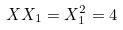Convert formula to latex. <formula><loc_0><loc_0><loc_500><loc_500>X X _ { 1 } = X _ { 1 } ^ { 2 } = 4</formula> 